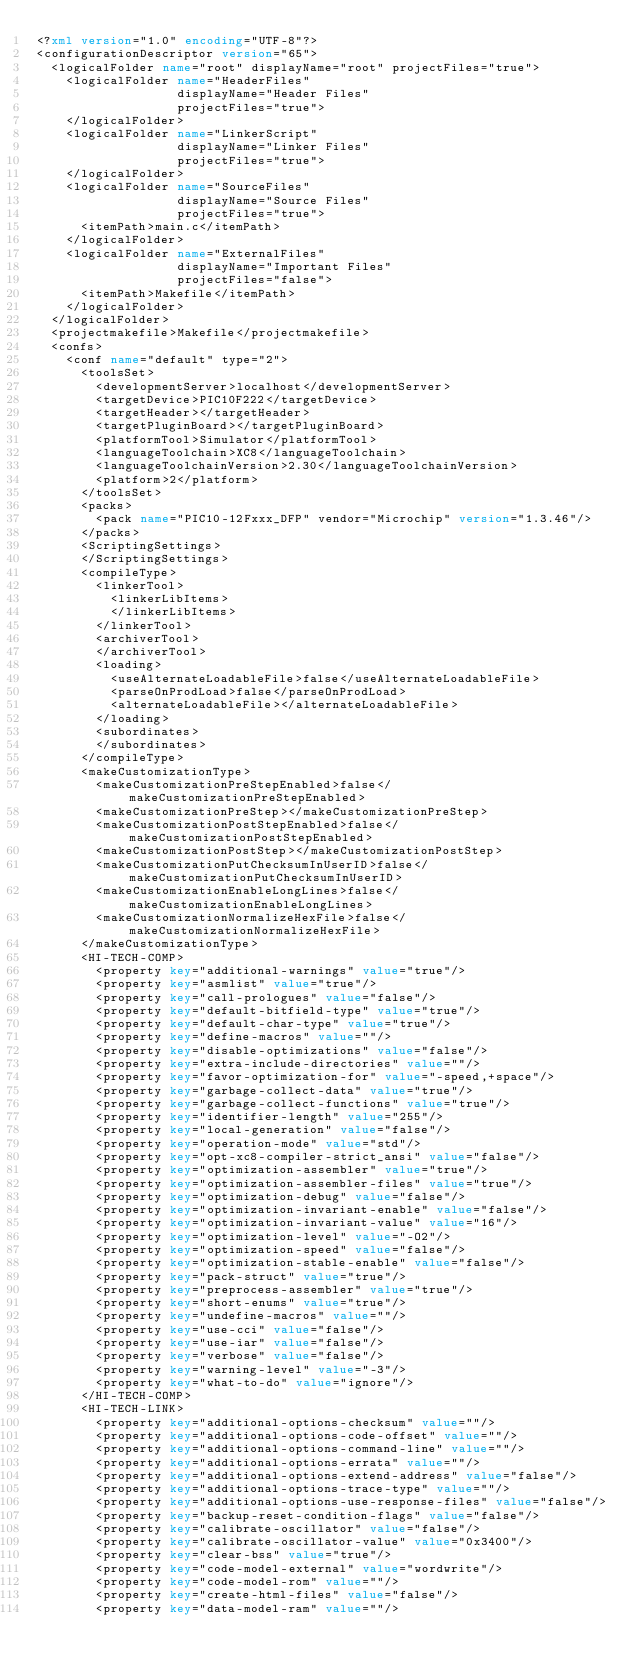<code> <loc_0><loc_0><loc_500><loc_500><_XML_><?xml version="1.0" encoding="UTF-8"?>
<configurationDescriptor version="65">
  <logicalFolder name="root" displayName="root" projectFiles="true">
    <logicalFolder name="HeaderFiles"
                   displayName="Header Files"
                   projectFiles="true">
    </logicalFolder>
    <logicalFolder name="LinkerScript"
                   displayName="Linker Files"
                   projectFiles="true">
    </logicalFolder>
    <logicalFolder name="SourceFiles"
                   displayName="Source Files"
                   projectFiles="true">
      <itemPath>main.c</itemPath>
    </logicalFolder>
    <logicalFolder name="ExternalFiles"
                   displayName="Important Files"
                   projectFiles="false">
      <itemPath>Makefile</itemPath>
    </logicalFolder>
  </logicalFolder>
  <projectmakefile>Makefile</projectmakefile>
  <confs>
    <conf name="default" type="2">
      <toolsSet>
        <developmentServer>localhost</developmentServer>
        <targetDevice>PIC10F222</targetDevice>
        <targetHeader></targetHeader>
        <targetPluginBoard></targetPluginBoard>
        <platformTool>Simulator</platformTool>
        <languageToolchain>XC8</languageToolchain>
        <languageToolchainVersion>2.30</languageToolchainVersion>
        <platform>2</platform>
      </toolsSet>
      <packs>
        <pack name="PIC10-12Fxxx_DFP" vendor="Microchip" version="1.3.46"/>
      </packs>
      <ScriptingSettings>
      </ScriptingSettings>
      <compileType>
        <linkerTool>
          <linkerLibItems>
          </linkerLibItems>
        </linkerTool>
        <archiverTool>
        </archiverTool>
        <loading>
          <useAlternateLoadableFile>false</useAlternateLoadableFile>
          <parseOnProdLoad>false</parseOnProdLoad>
          <alternateLoadableFile></alternateLoadableFile>
        </loading>
        <subordinates>
        </subordinates>
      </compileType>
      <makeCustomizationType>
        <makeCustomizationPreStepEnabled>false</makeCustomizationPreStepEnabled>
        <makeCustomizationPreStep></makeCustomizationPreStep>
        <makeCustomizationPostStepEnabled>false</makeCustomizationPostStepEnabled>
        <makeCustomizationPostStep></makeCustomizationPostStep>
        <makeCustomizationPutChecksumInUserID>false</makeCustomizationPutChecksumInUserID>
        <makeCustomizationEnableLongLines>false</makeCustomizationEnableLongLines>
        <makeCustomizationNormalizeHexFile>false</makeCustomizationNormalizeHexFile>
      </makeCustomizationType>
      <HI-TECH-COMP>
        <property key="additional-warnings" value="true"/>
        <property key="asmlist" value="true"/>
        <property key="call-prologues" value="false"/>
        <property key="default-bitfield-type" value="true"/>
        <property key="default-char-type" value="true"/>
        <property key="define-macros" value=""/>
        <property key="disable-optimizations" value="false"/>
        <property key="extra-include-directories" value=""/>
        <property key="favor-optimization-for" value="-speed,+space"/>
        <property key="garbage-collect-data" value="true"/>
        <property key="garbage-collect-functions" value="true"/>
        <property key="identifier-length" value="255"/>
        <property key="local-generation" value="false"/>
        <property key="operation-mode" value="std"/>
        <property key="opt-xc8-compiler-strict_ansi" value="false"/>
        <property key="optimization-assembler" value="true"/>
        <property key="optimization-assembler-files" value="true"/>
        <property key="optimization-debug" value="false"/>
        <property key="optimization-invariant-enable" value="false"/>
        <property key="optimization-invariant-value" value="16"/>
        <property key="optimization-level" value="-O2"/>
        <property key="optimization-speed" value="false"/>
        <property key="optimization-stable-enable" value="false"/>
        <property key="pack-struct" value="true"/>
        <property key="preprocess-assembler" value="true"/>
        <property key="short-enums" value="true"/>
        <property key="undefine-macros" value=""/>
        <property key="use-cci" value="false"/>
        <property key="use-iar" value="false"/>
        <property key="verbose" value="false"/>
        <property key="warning-level" value="-3"/>
        <property key="what-to-do" value="ignore"/>
      </HI-TECH-COMP>
      <HI-TECH-LINK>
        <property key="additional-options-checksum" value=""/>
        <property key="additional-options-code-offset" value=""/>
        <property key="additional-options-command-line" value=""/>
        <property key="additional-options-errata" value=""/>
        <property key="additional-options-extend-address" value="false"/>
        <property key="additional-options-trace-type" value=""/>
        <property key="additional-options-use-response-files" value="false"/>
        <property key="backup-reset-condition-flags" value="false"/>
        <property key="calibrate-oscillator" value="false"/>
        <property key="calibrate-oscillator-value" value="0x3400"/>
        <property key="clear-bss" value="true"/>
        <property key="code-model-external" value="wordwrite"/>
        <property key="code-model-rom" value=""/>
        <property key="create-html-files" value="false"/>
        <property key="data-model-ram" value=""/></code> 